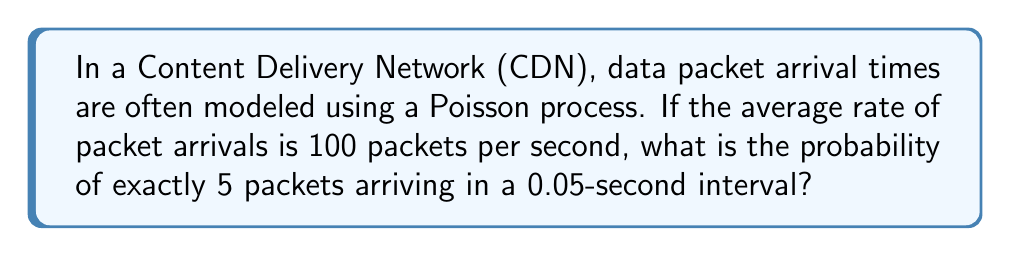Provide a solution to this math problem. To solve this problem, we'll use the Poisson distribution, which is appropriate for modeling the number of events occurring in a fixed interval of time when these events happen at a known average rate.

1. The Poisson distribution probability mass function is given by:

   $$P(X = k) = \frac{e^{-\lambda} \lambda^k}{k!}$$

   where:
   - $\lambda$ is the average number of events in the interval
   - $k$ is the number of events we're interested in
   - $e$ is Euler's number (approximately 2.71828)

2. Given:
   - Average rate = 100 packets/second
   - Time interval = 0.05 seconds
   - Number of packets we're interested in, $k = 5$

3. Calculate $\lambda$:
   $$\lambda = \text{rate} \times \text{time} = 100 \times 0.05 = 5$$

4. Now, we can plug these values into the Poisson probability mass function:

   $$P(X = 5) = \frac{e^{-5} 5^5}{5!}$$

5. Calculate step by step:
   
   $$P(X = 5) = \frac{e^{-5} \times 3125}{120}$$
   
   $$= \frac{0.006738 \times 3125}{120}$$
   
   $$= \frac{21.05625}{120}$$
   
   $$= 0.175468...$$

6. Round to 4 decimal places:

   $$P(X = 5) \approx 0.1755$$
Answer: 0.1755 